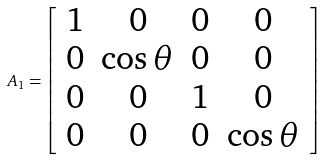Convert formula to latex. <formula><loc_0><loc_0><loc_500><loc_500>A _ { 1 } = \left [ \begin{array} { c c c c } 1 & 0 & 0 & 0 \\ 0 & \cos \theta & 0 & 0 \\ 0 & 0 & 1 & 0 \\ 0 & 0 & 0 & \cos \theta \end{array} \right ]</formula> 